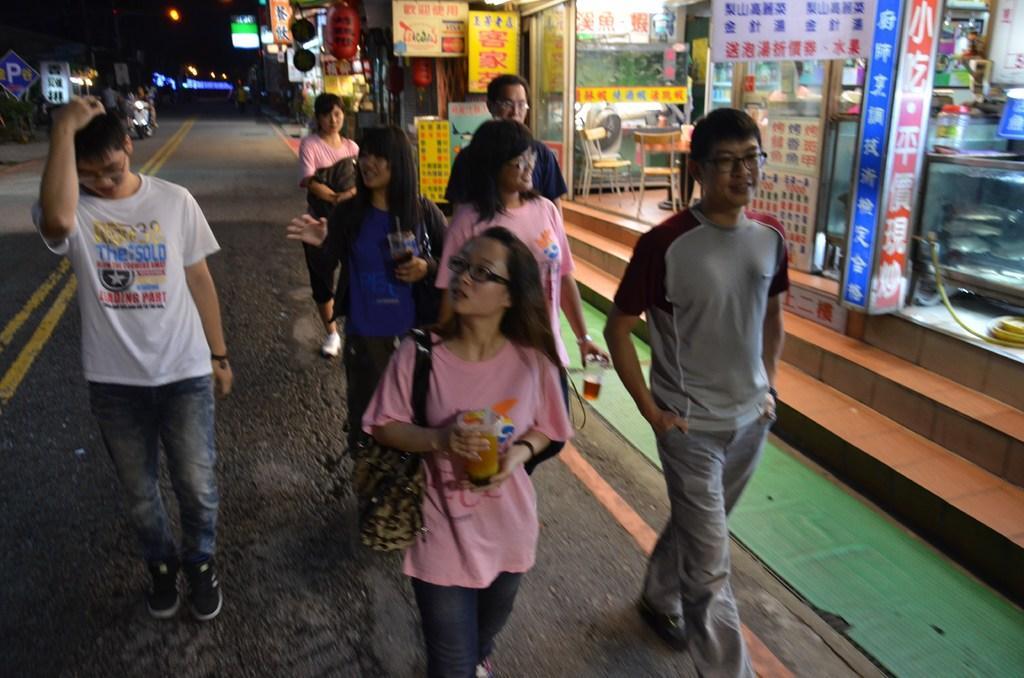In one or two sentences, can you explain what this image depicts? In this picture I can observe some people walking on the road. There are men and women in this picture. On the right side I can observe some stores. There is a vehicle on the left side. The background dark. 